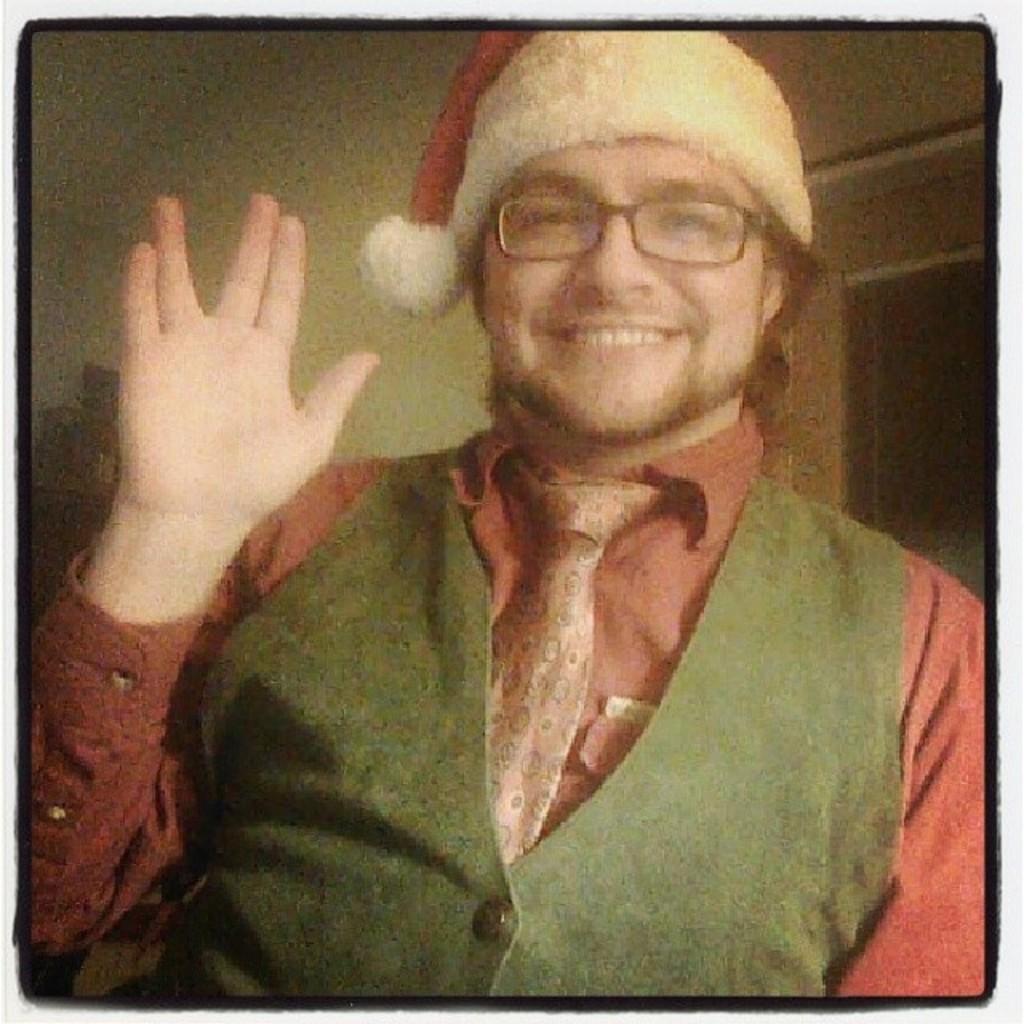Describe this image in one or two sentences. In this image we can see a man who is smiling, he is wearing red color shirt with green waist coat and Christmas cap. 